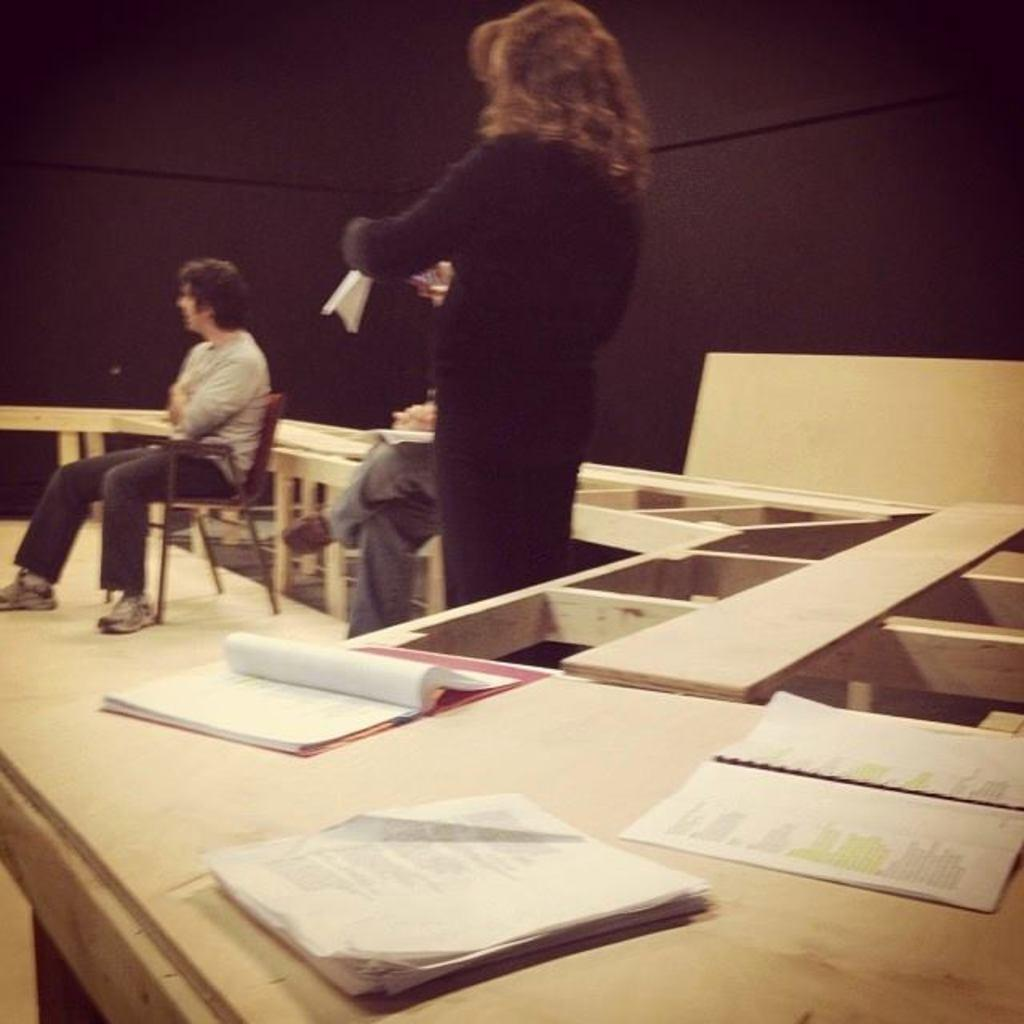How many people are present in the image? There are three people in the image. What else can be seen in the image besides the people? There are books in the image. What type of mask is being worn by the carpenter in the image? There is no carpenter or mask present in the image. 